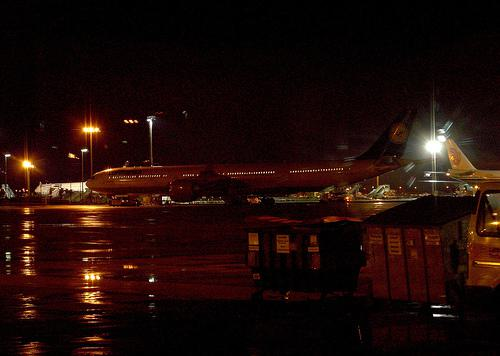Describe the lighting and setting of the image. The image captures a nighttime scene at an airport. The primary illumination comes from the terminal lights and ground service equipment, highlighting the reflective surfaces of the planes and the wet tarmac which reflects the lights, creating a glossy effect. Does this lighting affect the operation of the airport? Yes, the artificial lighting is crucial for nighttime operations, allowing for safe maneuvering of aircraft and ground vehicles. It ensures visibility for pilots, ground staff, and air traffic controllers to coordinate safely. 